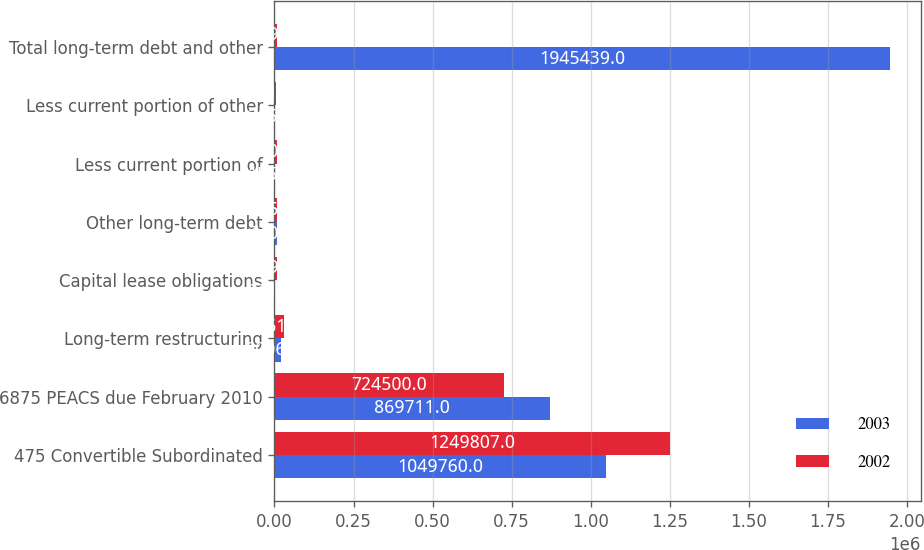Convert chart. <chart><loc_0><loc_0><loc_500><loc_500><stacked_bar_chart><ecel><fcel>475 Convertible Subordinated<fcel>6875 PEACS due February 2010<fcel>Long-term restructuring<fcel>Capital lease obligations<fcel>Other long-term debt<fcel>Less current portion of<fcel>Less current portion of other<fcel>Total long-term debt and other<nl><fcel>2003<fcel>1.04976e+06<fcel>869711<fcel>20066<fcel>2717<fcel>7401<fcel>1558<fcel>2658<fcel>1.94544e+06<nl><fcel>2002<fcel>1.24981e+06<fcel>724500<fcel>31614<fcel>8491<fcel>8456<fcel>7506<fcel>5813<fcel>8491<nl></chart> 